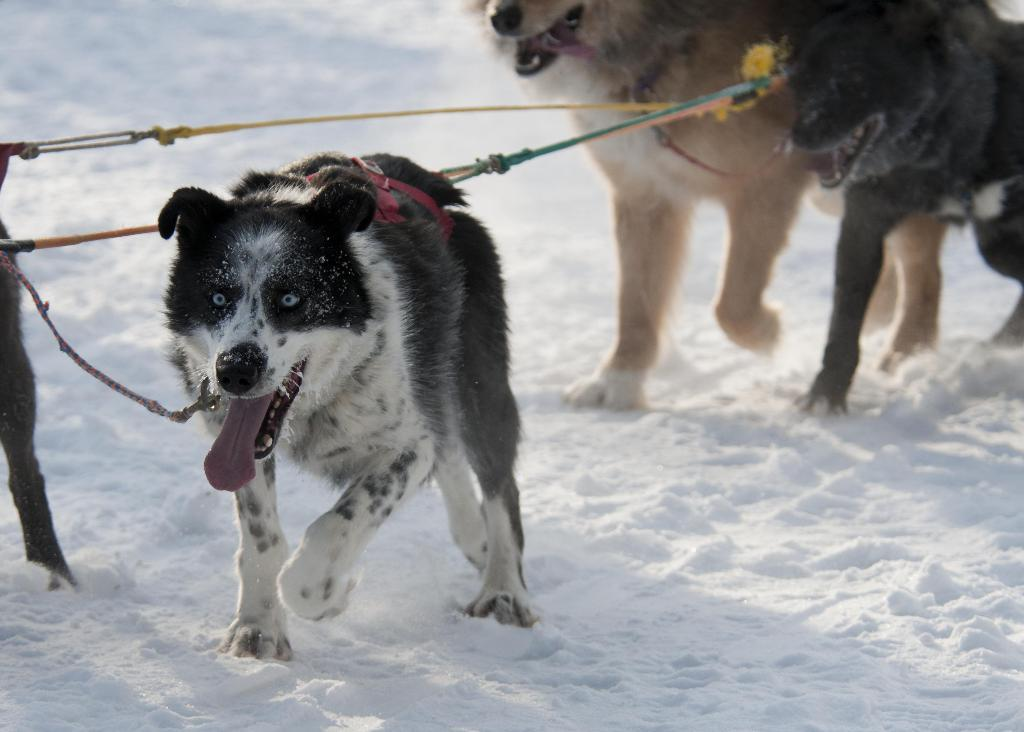What animals are present in the image? There are dogs in the image. How are the dogs restrained in the image? The dogs are tied with ropes. What type of weather condition is depicted in the image? There is snow visible at the bottom portion of the image. What type of dust can be seen in the image? There is no dust present in the image. What amusement park can be seen in the background of the image? There is no amusement park visible in the image; it features dogs tied with ropes in the snow. 